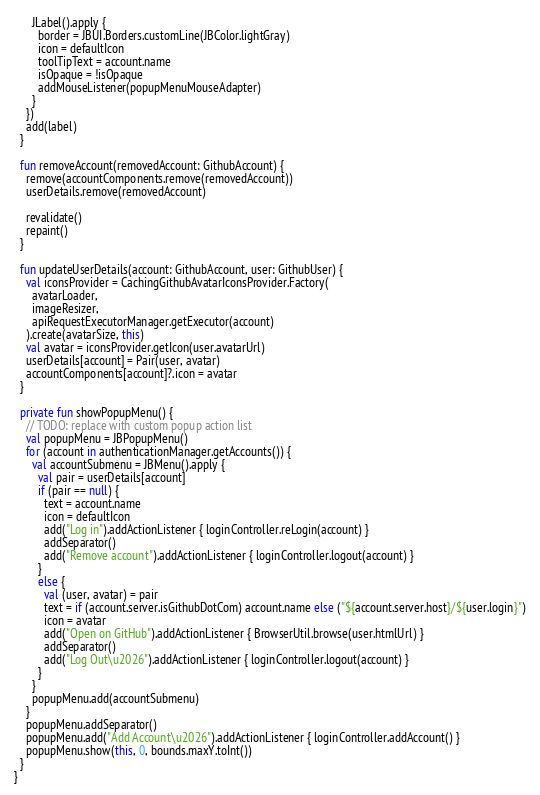<code> <loc_0><loc_0><loc_500><loc_500><_Kotlin_>      JLabel().apply {
        border = JBUI.Borders.customLine(JBColor.lightGray)
        icon = defaultIcon
        toolTipText = account.name
        isOpaque = !isOpaque
        addMouseListener(popupMenuMouseAdapter)
      }
    })
    add(label)
  }

  fun removeAccount(removedAccount: GithubAccount) {
    remove(accountComponents.remove(removedAccount))
    userDetails.remove(removedAccount)

    revalidate()
    repaint()
  }

  fun updateUserDetails(account: GithubAccount, user: GithubUser) {
    val iconsProvider = CachingGithubAvatarIconsProvider.Factory(
      avatarLoader,
      imageResizer,
      apiRequestExecutorManager.getExecutor(account)
    ).create(avatarSize, this)
    val avatar = iconsProvider.getIcon(user.avatarUrl)
    userDetails[account] = Pair(user, avatar)
    accountComponents[account]?.icon = avatar
  }

  private fun showPopupMenu() {
    // TODO: replace with custom popup action list
    val popupMenu = JBPopupMenu()
    for (account in authenticationManager.getAccounts()) {
      val accountSubmenu = JBMenu().apply {
        val pair = userDetails[account]
        if (pair == null) {
          text = account.name
          icon = defaultIcon
          add("Log in").addActionListener { loginController.reLogin(account) }
          addSeparator()
          add("Remove account").addActionListener { loginController.logout(account) }
        }
        else {
          val (user, avatar) = pair
          text = if (account.server.isGithubDotCom) account.name else ("${account.server.host}/${user.login}")
          icon = avatar
          add("Open on GitHub").addActionListener { BrowserUtil.browse(user.htmlUrl) }
          addSeparator()
          add("Log Out\u2026").addActionListener { loginController.logout(account) }
        }
      }
      popupMenu.add(accountSubmenu)
    }
    popupMenu.addSeparator()
    popupMenu.add("Add Account\u2026").addActionListener { loginController.addAccount() }
    popupMenu.show(this, 0, bounds.maxY.toInt())
  }
}</code> 